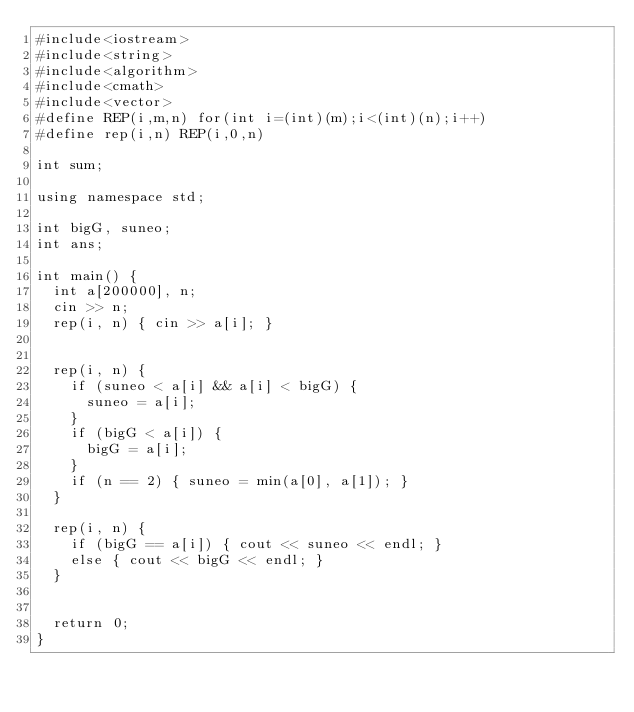Convert code to text. <code><loc_0><loc_0><loc_500><loc_500><_C++_>#include<iostream>
#include<string>
#include<algorithm>
#include<cmath>
#include<vector>
#define REP(i,m,n) for(int i=(int)(m);i<(int)(n);i++)
#define rep(i,n) REP(i,0,n)

int sum;

using namespace std;

int bigG, suneo;
int ans;

int main() {
	int a[200000], n;
	cin >> n;
	rep(i, n) { cin >> a[i]; }


	rep(i, n) {
		if (suneo < a[i] && a[i] < bigG) {
			suneo = a[i];
		}
		if (bigG < a[i]) {
			bigG = a[i];
		}
		if (n == 2) { suneo = min(a[0], a[1]); }
	}

	rep(i, n) {
		if (bigG == a[i]) { cout << suneo << endl; }
		else { cout << bigG << endl; }
	}


	return 0;
}</code> 